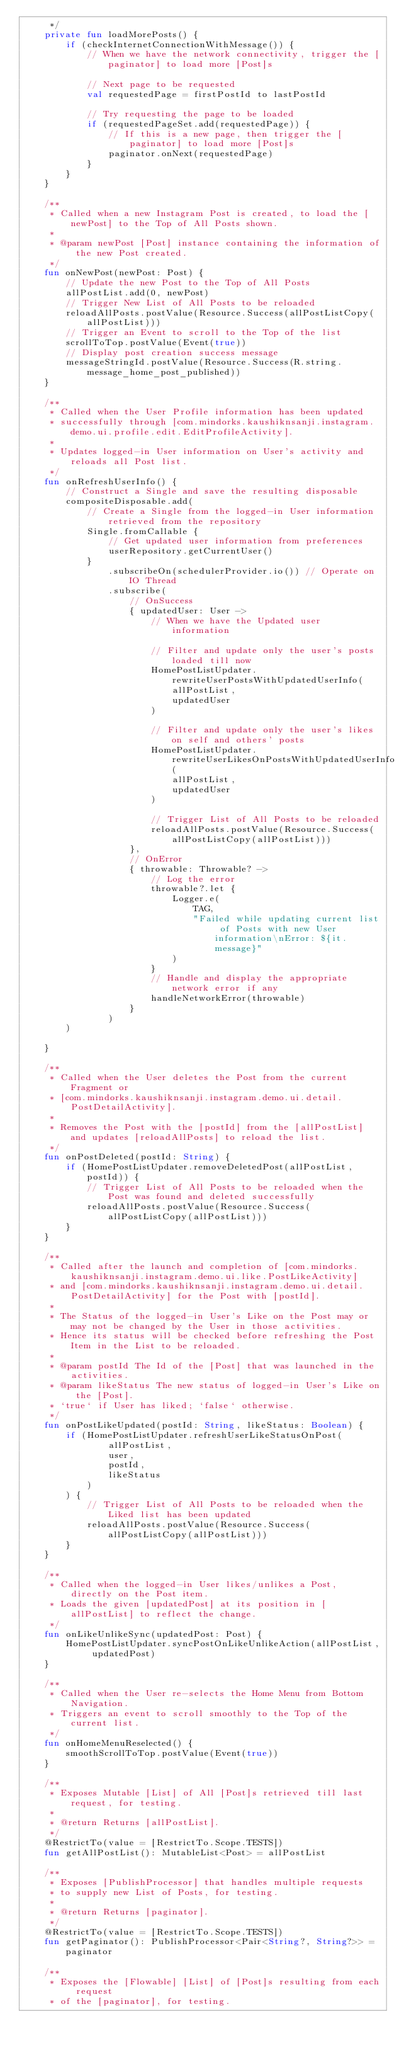Convert code to text. <code><loc_0><loc_0><loc_500><loc_500><_Kotlin_>     */
    private fun loadMorePosts() {
        if (checkInternetConnectionWithMessage()) {
            // When we have the network connectivity, trigger the [paginator] to load more [Post]s

            // Next page to be requested
            val requestedPage = firstPostId to lastPostId

            // Try requesting the page to be loaded
            if (requestedPageSet.add(requestedPage)) {
                // If this is a new page, then trigger the [paginator] to load more [Post]s
                paginator.onNext(requestedPage)
            }
        }
    }

    /**
     * Called when a new Instagram Post is created, to load the [newPost] to the Top of All Posts shown.
     *
     * @param newPost [Post] instance containing the information of the new Post created.
     */
    fun onNewPost(newPost: Post) {
        // Update the new Post to the Top of All Posts
        allPostList.add(0, newPost)
        // Trigger New List of All Posts to be reloaded
        reloadAllPosts.postValue(Resource.Success(allPostListCopy(allPostList)))
        // Trigger an Event to scroll to the Top of the list
        scrollToTop.postValue(Event(true))
        // Display post creation success message
        messageStringId.postValue(Resource.Success(R.string.message_home_post_published))
    }

    /**
     * Called when the User Profile information has been updated
     * successfully through [com.mindorks.kaushiknsanji.instagram.demo.ui.profile.edit.EditProfileActivity].
     *
     * Updates logged-in User information on User's activity and reloads all Post list.
     */
    fun onRefreshUserInfo() {
        // Construct a Single and save the resulting disposable
        compositeDisposable.add(
            // Create a Single from the logged-in User information retrieved from the repository
            Single.fromCallable {
                // Get updated user information from preferences
                userRepository.getCurrentUser()
            }
                .subscribeOn(schedulerProvider.io()) // Operate on IO Thread
                .subscribe(
                    // OnSuccess
                    { updatedUser: User ->
                        // When we have the Updated user information

                        // Filter and update only the user's posts loaded till now
                        HomePostListUpdater.rewriteUserPostsWithUpdatedUserInfo(
                            allPostList,
                            updatedUser
                        )

                        // Filter and update only the user's likes on self and others' posts
                        HomePostListUpdater.rewriteUserLikesOnPostsWithUpdatedUserInfo(
                            allPostList,
                            updatedUser
                        )

                        // Trigger List of All Posts to be reloaded
                        reloadAllPosts.postValue(Resource.Success(allPostListCopy(allPostList)))
                    },
                    // OnError
                    { throwable: Throwable? ->
                        // Log the error
                        throwable?.let {
                            Logger.e(
                                TAG,
                                "Failed while updating current list of Posts with new User information\nError: ${it.message}"
                            )
                        }
                        // Handle and display the appropriate network error if any
                        handleNetworkError(throwable)
                    }
                )
        )

    }

    /**
     * Called when the User deletes the Post from the current Fragment or
     * [com.mindorks.kaushiknsanji.instagram.demo.ui.detail.PostDetailActivity].
     *
     * Removes the Post with the [postId] from the [allPostList] and updates [reloadAllPosts] to reload the list.
     */
    fun onPostDeleted(postId: String) {
        if (HomePostListUpdater.removeDeletedPost(allPostList, postId)) {
            // Trigger List of All Posts to be reloaded when the Post was found and deleted successfully
            reloadAllPosts.postValue(Resource.Success(allPostListCopy(allPostList)))
        }
    }

    /**
     * Called after the launch and completion of [com.mindorks.kaushiknsanji.instagram.demo.ui.like.PostLikeActivity]
     * and [com.mindorks.kaushiknsanji.instagram.demo.ui.detail.PostDetailActivity] for the Post with [postId].
     *
     * The Status of the logged-in User's Like on the Post may or may not be changed by the User in those activities.
     * Hence its status will be checked before refreshing the Post Item in the List to be reloaded.
     *
     * @param postId The Id of the [Post] that was launched in the activities.
     * @param likeStatus The new status of logged-in User's Like on the [Post].
     * `true` if User has liked; `false` otherwise.
     */
    fun onPostLikeUpdated(postId: String, likeStatus: Boolean) {
        if (HomePostListUpdater.refreshUserLikeStatusOnPost(
                allPostList,
                user,
                postId,
                likeStatus
            )
        ) {
            // Trigger List of All Posts to be reloaded when the Liked list has been updated
            reloadAllPosts.postValue(Resource.Success(allPostListCopy(allPostList)))
        }
    }

    /**
     * Called when the logged-in User likes/unlikes a Post, directly on the Post item.
     * Loads the given [updatedPost] at its position in [allPostList] to reflect the change.
     */
    fun onLikeUnlikeSync(updatedPost: Post) {
        HomePostListUpdater.syncPostOnLikeUnlikeAction(allPostList, updatedPost)
    }

    /**
     * Called when the User re-selects the Home Menu from Bottom Navigation.
     * Triggers an event to scroll smoothly to the Top of the current list.
     */
    fun onHomeMenuReselected() {
        smoothScrollToTop.postValue(Event(true))
    }

    /**
     * Exposes Mutable [List] of All [Post]s retrieved till last request, for testing.
     *
     * @return Returns [allPostList].
     */
    @RestrictTo(value = [RestrictTo.Scope.TESTS])
    fun getAllPostList(): MutableList<Post> = allPostList

    /**
     * Exposes [PublishProcessor] that handles multiple requests
     * to supply new List of Posts, for testing.
     *
     * @return Returns [paginator].
     */
    @RestrictTo(value = [RestrictTo.Scope.TESTS])
    fun getPaginator(): PublishProcessor<Pair<String?, String?>> = paginator

    /**
     * Exposes the [Flowable] [List] of [Post]s resulting from each request
     * of the [paginator], for testing.</code> 